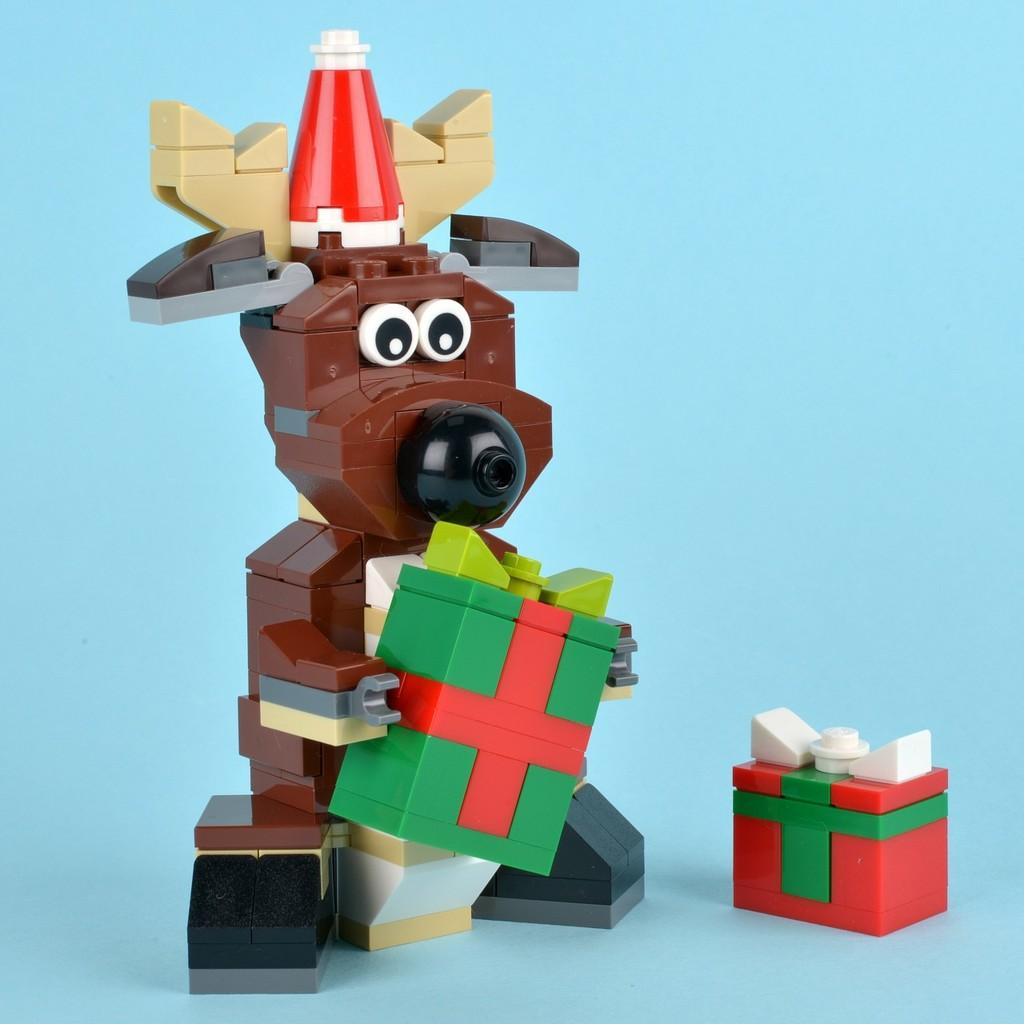What type of toy is in the image? There is a brown toy in the image. What is the toy holding? The toy is holding a green and red color box. What color is the background of the image? The background of the image is blue. What is the temperature in the yard during the month of June in the image? There is no information about the yard, month, or temperature in the image. The image only shows a brown toy holding a green and red color box with a blue background. 